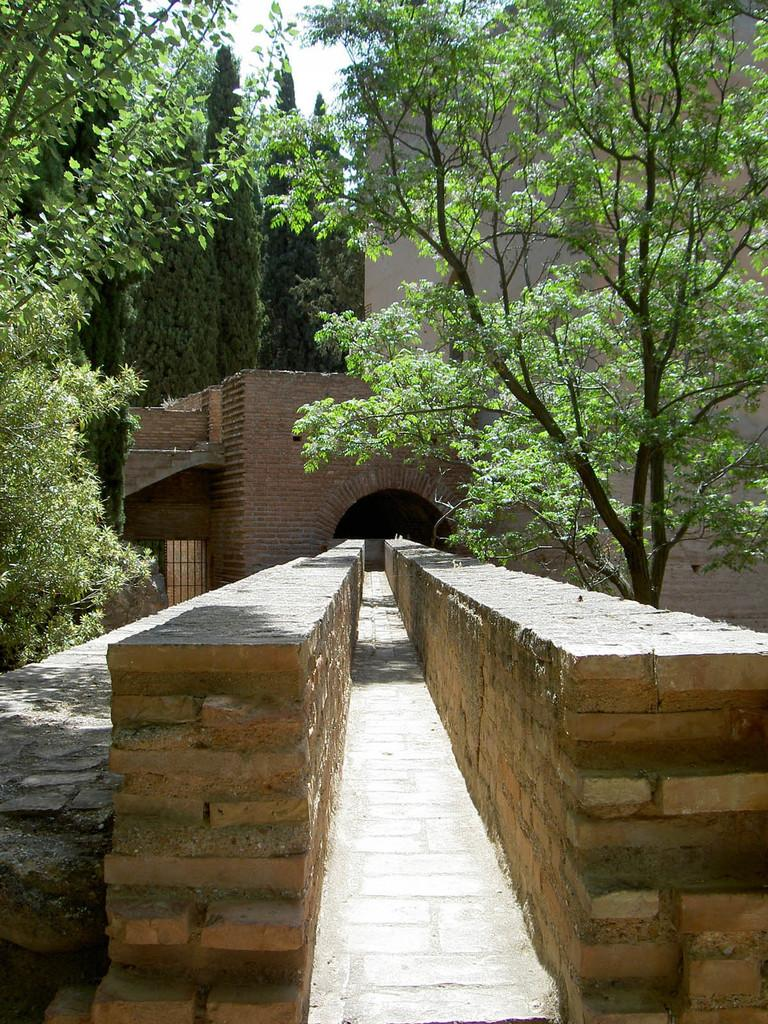What type of vegetation can be seen in the image? There are trees in the image. What is the color of the trees? The trees are green. What type of structures are present in the image? There are buildings in the image. What colors are the buildings? The buildings are in brown and cream colors. What is visible in the sky in the image? The sky is white in the image. What type of pen is being used to write on the trees in the image? There is no pen or writing on the trees in the image; they are simply green trees in a natural setting. 